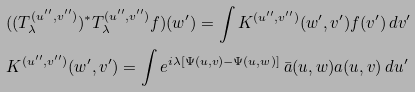<formula> <loc_0><loc_0><loc_500><loc_500>& ( ( T ^ { ( u ^ { \prime \prime } , v ^ { \prime \prime } ) } _ { \lambda } ) ^ { * } T ^ { ( u ^ { \prime \prime } , v ^ { \prime \prime } ) } _ { \lambda } f ) ( w ^ { \prime } ) = \int K ^ { ( u ^ { \prime \prime } , v ^ { \prime \prime } ) } ( w ^ { \prime } , v ^ { \prime } ) f ( v ^ { \prime } ) \, d v ^ { \prime } \\ & K ^ { ( u ^ { \prime \prime } , v ^ { \prime \prime } ) } ( w ^ { \prime } , v ^ { \prime } ) = \int e ^ { i \lambda [ \Psi ( u , v ) - \Psi ( u , w ) ] } \, \bar { a } ( u , w ) a ( u , v ) \, d u ^ { \prime }</formula> 